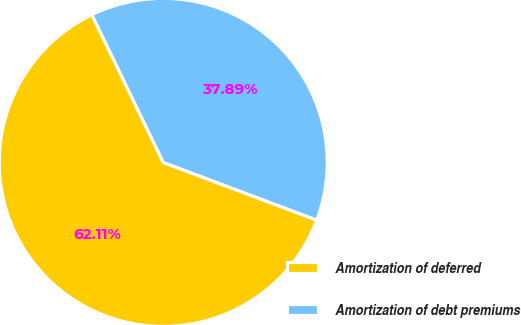Convert chart to OTSL. <chart><loc_0><loc_0><loc_500><loc_500><pie_chart><fcel>Amortization of deferred<fcel>Amortization of debt premiums<nl><fcel>62.11%<fcel>37.89%<nl></chart> 